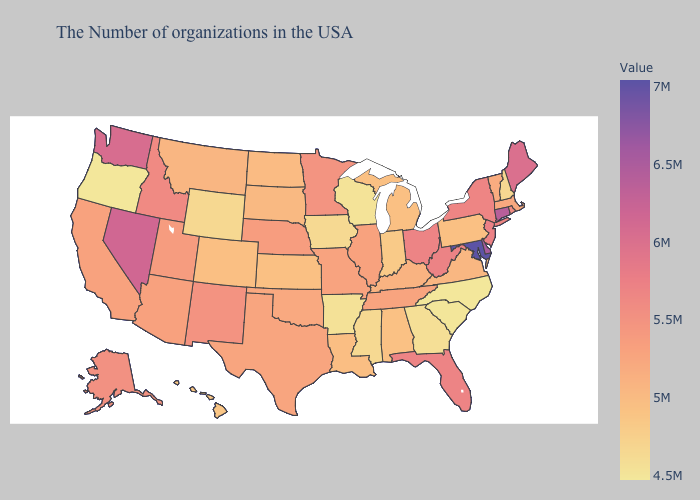Does Connecticut have the highest value in the Northeast?
Concise answer only. Yes. Does Washington have a higher value than New Mexico?
Short answer required. Yes. Among the states that border New Mexico , which have the highest value?
Keep it brief. Utah. Among the states that border California , which have the highest value?
Give a very brief answer. Nevada. Among the states that border Minnesota , which have the highest value?
Keep it brief. South Dakota. Does Connecticut have the highest value in the Northeast?
Be succinct. Yes. Among the states that border Vermont , which have the highest value?
Short answer required. New York. 